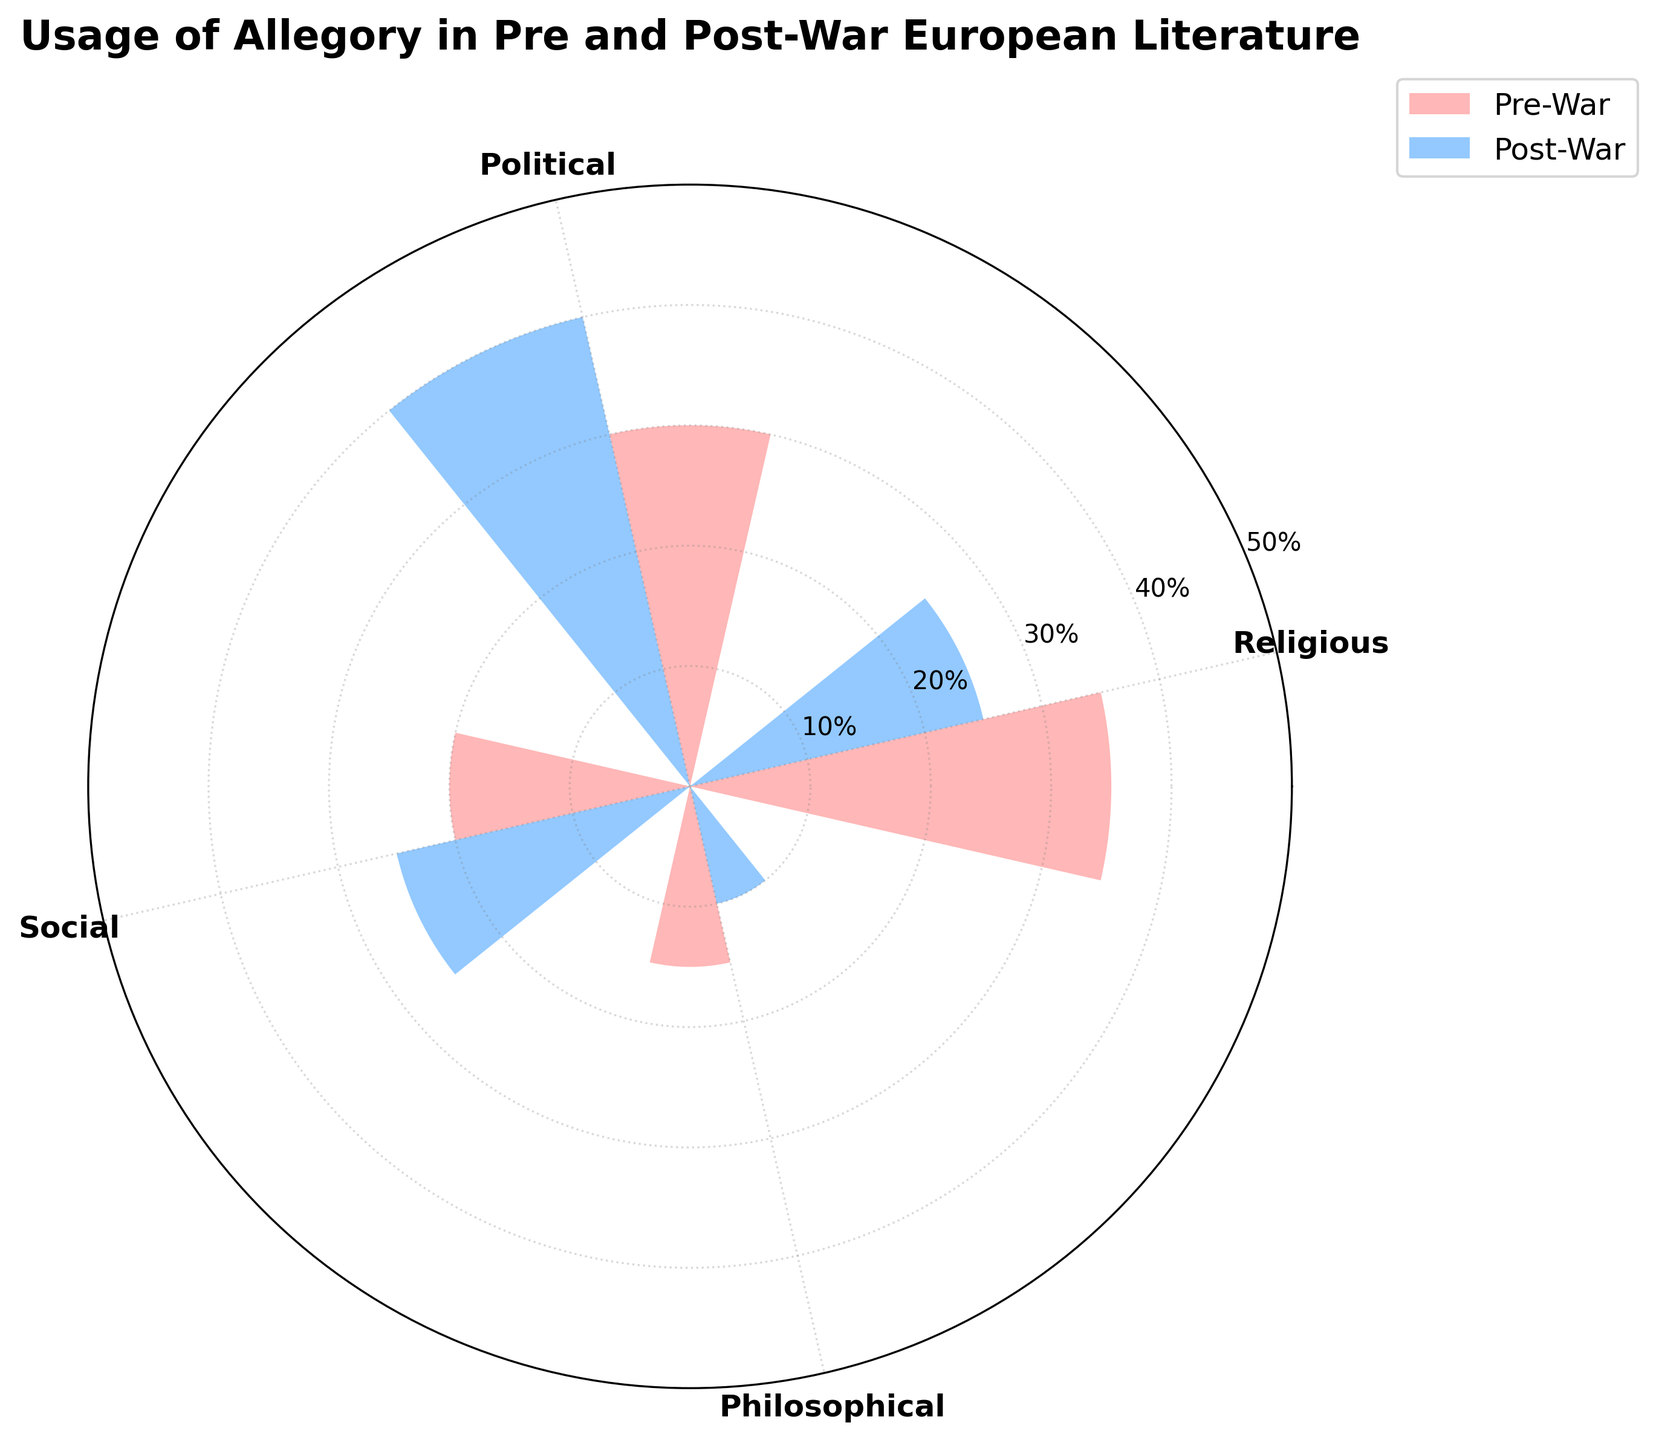What are the categories of allegory shown in the chart? The categories are labeled on the radial axis of the rose chart. By reading the labels, we can identify the categories.
Answer: Religious, Political, Social, Philosophical How does the usage of religious allegory change from pre-war to post-war? Compare the heights of the bars representing religious allegory for the pre-war and post-war periods. The pre-war bar is higher than the post-war bar.
Answer: It decreases Which period has a higher percentage of political allegory usage? Compare the bars for political allegory in both periods by looking at their lengths. The post-war political allegory bar is taller.
Answer: Post-War What is the combined percentage of social and philosophical allegory usage in the post-war period? Add the percentages of social (25%) and philosophical (10%) allegories from the post-war period. Perform the addition: 25% + 10%.
Answer: 35% What is the percentage difference in the usage of political allegory between the pre-war and post-war periods? Subtract the pre-war percentage of political allegory (30%) from the post-war percentage (40%). Perform the subtraction: 40% - 30%.
Answer: 10% Which type of allegory has the largest reduction in usage percentage from pre-war to post-war periods? Calculate the reduction for each type:
Religious: 35% - 25% = 10%
Political: 30% - 40% = -10%
Social: 20% - 25% = -5%
Philosophical: 15% - 10% = 5%
The largest positive value is for Religious allegory, which indicates a reduction.
Answer: Religious What is the total percentage of allegory usage in the pre-war period? Sum the usage percentages of all allegory types in the pre-war period:
Religious: 35%
Political: 30%
Social: 20%
Philosophical: 15%
Perform the addition: 35% + 30% + 20% + 15%.
Answer: 100% How does the usage of social allegory compare between the two periods? Compare the heights of the bars for social allegory in both periods. The post-war bar is slightly taller than the pre-war bar.
Answer: It increases 